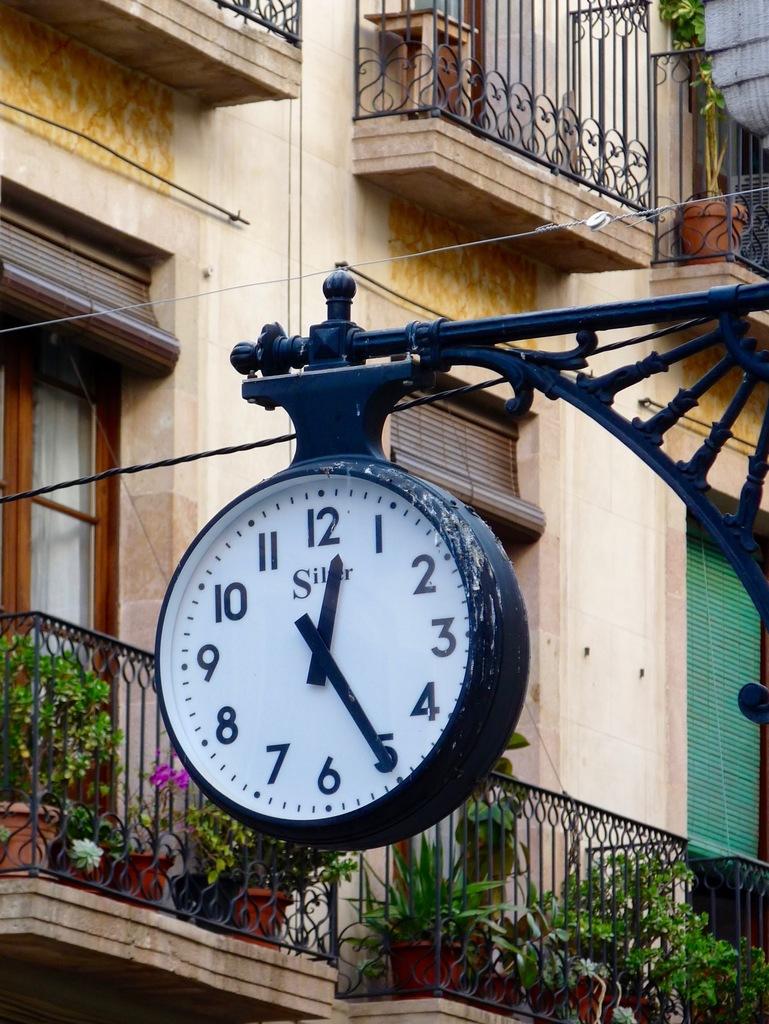What number is the minute hand pointing to?
Your answer should be very brief. 5. What number is the hour hand pointing to?
Your response must be concise. 12. 